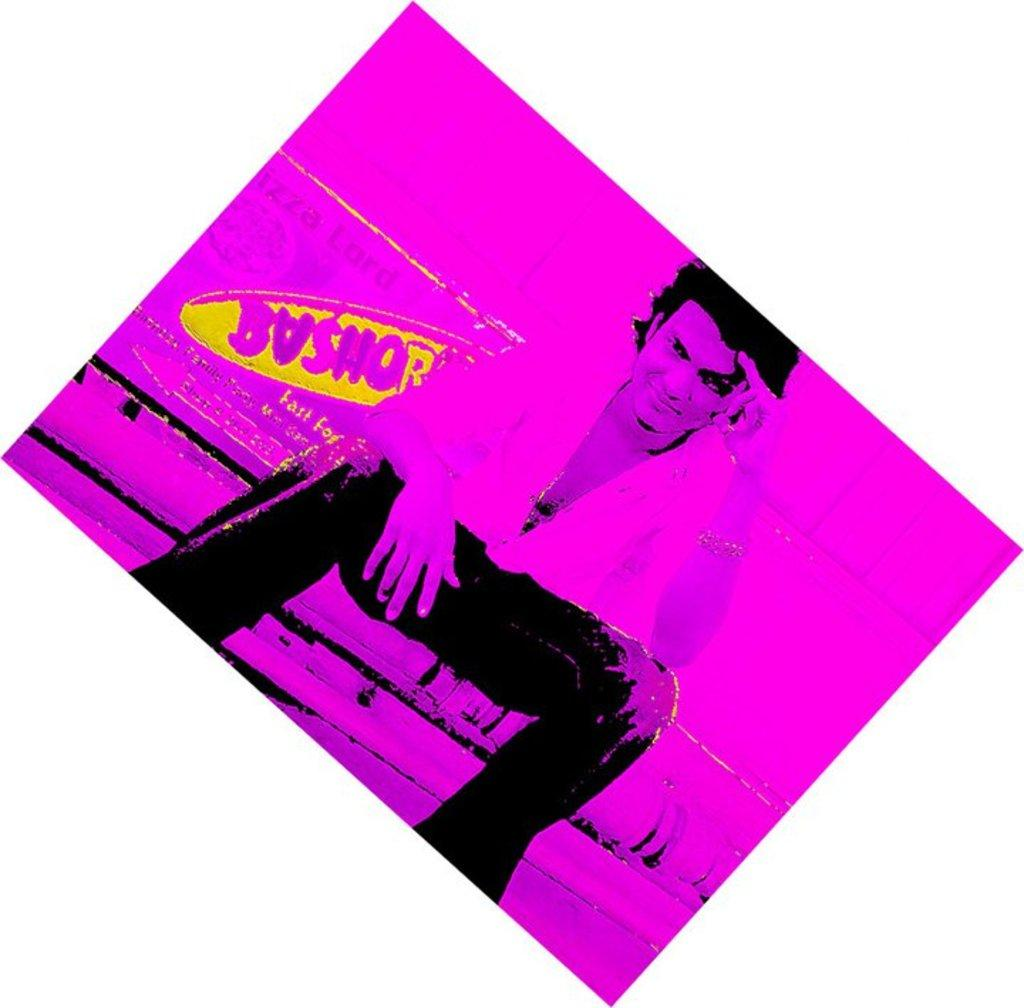What is the person in the image doing? There is a person sitting in the image. What else can be seen in the image besides the person? There is text in the image. What color dominates the image? The image is in pink color. What type of copper egg can be seen in the image? There is no copper egg present in the image. How does the person wash their hands in the image? There is no indication of handwashing or any related activity in the image. 